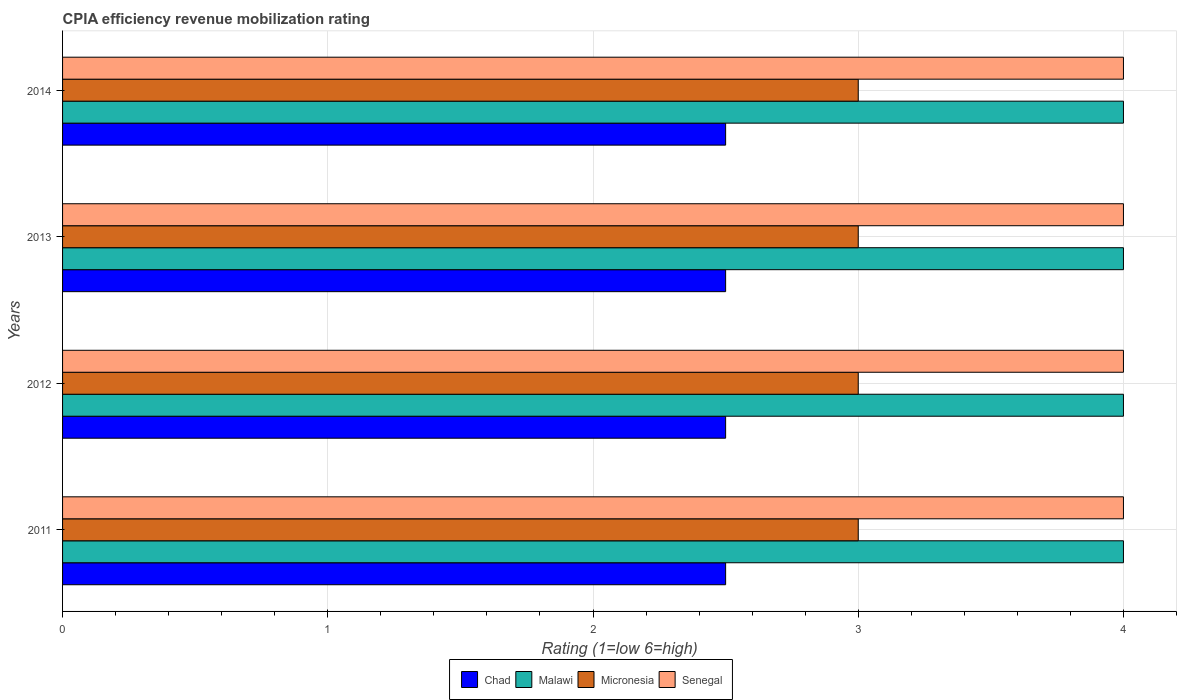How many groups of bars are there?
Provide a succinct answer. 4. Are the number of bars per tick equal to the number of legend labels?
Your answer should be very brief. Yes. Are the number of bars on each tick of the Y-axis equal?
Your answer should be compact. Yes. How many bars are there on the 2nd tick from the top?
Offer a very short reply. 4. In how many cases, is the number of bars for a given year not equal to the number of legend labels?
Provide a short and direct response. 0. Across all years, what is the maximum CPIA rating in Malawi?
Your answer should be compact. 4. In which year was the CPIA rating in Malawi maximum?
Give a very brief answer. 2011. In which year was the CPIA rating in Senegal minimum?
Your response must be concise. 2011. What is the total CPIA rating in Malawi in the graph?
Offer a very short reply. 16. What is the difference between the CPIA rating in Senegal in 2013 and that in 2014?
Ensure brevity in your answer.  0. What is the average CPIA rating in Chad per year?
Provide a short and direct response. 2.5. In how many years, is the CPIA rating in Senegal greater than 3.4 ?
Your answer should be very brief. 4. What is the ratio of the CPIA rating in Micronesia in 2011 to that in 2014?
Make the answer very short. 1. Is the CPIA rating in Micronesia in 2012 less than that in 2014?
Provide a short and direct response. No. What is the difference between the highest and the lowest CPIA rating in Malawi?
Your response must be concise. 0. In how many years, is the CPIA rating in Malawi greater than the average CPIA rating in Malawi taken over all years?
Your answer should be compact. 0. Is the sum of the CPIA rating in Chad in 2013 and 2014 greater than the maximum CPIA rating in Malawi across all years?
Ensure brevity in your answer.  Yes. Is it the case that in every year, the sum of the CPIA rating in Chad and CPIA rating in Micronesia is greater than the sum of CPIA rating in Senegal and CPIA rating in Malawi?
Your response must be concise. Yes. What does the 3rd bar from the top in 2013 represents?
Provide a succinct answer. Malawi. What does the 2nd bar from the bottom in 2011 represents?
Offer a terse response. Malawi. Is it the case that in every year, the sum of the CPIA rating in Chad and CPIA rating in Senegal is greater than the CPIA rating in Micronesia?
Your response must be concise. Yes. Are all the bars in the graph horizontal?
Offer a very short reply. Yes. How many years are there in the graph?
Ensure brevity in your answer.  4. What is the difference between two consecutive major ticks on the X-axis?
Give a very brief answer. 1. Does the graph contain any zero values?
Your response must be concise. No. Where does the legend appear in the graph?
Keep it short and to the point. Bottom center. What is the title of the graph?
Your response must be concise. CPIA efficiency revenue mobilization rating. What is the label or title of the X-axis?
Offer a terse response. Rating (1=low 6=high). What is the label or title of the Y-axis?
Make the answer very short. Years. What is the Rating (1=low 6=high) in Malawi in 2011?
Provide a succinct answer. 4. What is the Rating (1=low 6=high) in Senegal in 2011?
Ensure brevity in your answer.  4. What is the Rating (1=low 6=high) of Micronesia in 2012?
Offer a terse response. 3. What is the Rating (1=low 6=high) in Senegal in 2012?
Offer a terse response. 4. What is the Rating (1=low 6=high) in Malawi in 2013?
Your answer should be compact. 4. What is the Rating (1=low 6=high) of Malawi in 2014?
Your answer should be very brief. 4. What is the Rating (1=low 6=high) of Micronesia in 2014?
Keep it short and to the point. 3. Across all years, what is the maximum Rating (1=low 6=high) of Chad?
Your response must be concise. 2.5. Across all years, what is the minimum Rating (1=low 6=high) of Chad?
Keep it short and to the point. 2.5. Across all years, what is the minimum Rating (1=low 6=high) in Malawi?
Your response must be concise. 4. Across all years, what is the minimum Rating (1=low 6=high) of Micronesia?
Provide a short and direct response. 3. Across all years, what is the minimum Rating (1=low 6=high) of Senegal?
Give a very brief answer. 4. What is the total Rating (1=low 6=high) of Chad in the graph?
Ensure brevity in your answer.  10. What is the total Rating (1=low 6=high) of Malawi in the graph?
Give a very brief answer. 16. What is the total Rating (1=low 6=high) of Micronesia in the graph?
Keep it short and to the point. 12. What is the total Rating (1=low 6=high) of Senegal in the graph?
Provide a short and direct response. 16. What is the difference between the Rating (1=low 6=high) of Chad in 2011 and that in 2013?
Ensure brevity in your answer.  0. What is the difference between the Rating (1=low 6=high) in Senegal in 2011 and that in 2013?
Provide a succinct answer. 0. What is the difference between the Rating (1=low 6=high) in Chad in 2011 and that in 2014?
Your answer should be very brief. 0. What is the difference between the Rating (1=low 6=high) in Senegal in 2011 and that in 2014?
Give a very brief answer. 0. What is the difference between the Rating (1=low 6=high) in Chad in 2012 and that in 2013?
Give a very brief answer. 0. What is the difference between the Rating (1=low 6=high) of Senegal in 2012 and that in 2013?
Your response must be concise. 0. What is the difference between the Rating (1=low 6=high) of Micronesia in 2012 and that in 2014?
Provide a short and direct response. 0. What is the difference between the Rating (1=low 6=high) in Chad in 2013 and that in 2014?
Your answer should be very brief. 0. What is the difference between the Rating (1=low 6=high) of Chad in 2011 and the Rating (1=low 6=high) of Malawi in 2012?
Make the answer very short. -1.5. What is the difference between the Rating (1=low 6=high) of Chad in 2011 and the Rating (1=low 6=high) of Micronesia in 2012?
Make the answer very short. -0.5. What is the difference between the Rating (1=low 6=high) of Chad in 2011 and the Rating (1=low 6=high) of Senegal in 2012?
Your answer should be very brief. -1.5. What is the difference between the Rating (1=low 6=high) of Malawi in 2011 and the Rating (1=low 6=high) of Senegal in 2012?
Offer a very short reply. 0. What is the difference between the Rating (1=low 6=high) of Chad in 2011 and the Rating (1=low 6=high) of Malawi in 2013?
Your response must be concise. -1.5. What is the difference between the Rating (1=low 6=high) in Chad in 2011 and the Rating (1=low 6=high) in Senegal in 2013?
Make the answer very short. -1.5. What is the difference between the Rating (1=low 6=high) in Malawi in 2011 and the Rating (1=low 6=high) in Micronesia in 2013?
Your response must be concise. 1. What is the difference between the Rating (1=low 6=high) in Micronesia in 2011 and the Rating (1=low 6=high) in Senegal in 2013?
Offer a very short reply. -1. What is the difference between the Rating (1=low 6=high) of Chad in 2011 and the Rating (1=low 6=high) of Micronesia in 2014?
Offer a very short reply. -0.5. What is the difference between the Rating (1=low 6=high) in Chad in 2011 and the Rating (1=low 6=high) in Senegal in 2014?
Your answer should be compact. -1.5. What is the difference between the Rating (1=low 6=high) of Malawi in 2011 and the Rating (1=low 6=high) of Micronesia in 2014?
Give a very brief answer. 1. What is the difference between the Rating (1=low 6=high) in Malawi in 2011 and the Rating (1=low 6=high) in Senegal in 2014?
Offer a very short reply. 0. What is the difference between the Rating (1=low 6=high) of Micronesia in 2011 and the Rating (1=low 6=high) of Senegal in 2014?
Offer a terse response. -1. What is the difference between the Rating (1=low 6=high) of Chad in 2012 and the Rating (1=low 6=high) of Micronesia in 2013?
Give a very brief answer. -0.5. What is the difference between the Rating (1=low 6=high) in Malawi in 2012 and the Rating (1=low 6=high) in Micronesia in 2013?
Your response must be concise. 1. What is the difference between the Rating (1=low 6=high) of Chad in 2012 and the Rating (1=low 6=high) of Malawi in 2014?
Provide a succinct answer. -1.5. What is the difference between the Rating (1=low 6=high) of Micronesia in 2012 and the Rating (1=low 6=high) of Senegal in 2014?
Your response must be concise. -1. What is the difference between the Rating (1=low 6=high) in Chad in 2013 and the Rating (1=low 6=high) in Malawi in 2014?
Your answer should be very brief. -1.5. What is the difference between the Rating (1=low 6=high) in Chad in 2013 and the Rating (1=low 6=high) in Micronesia in 2014?
Give a very brief answer. -0.5. What is the difference between the Rating (1=low 6=high) of Malawi in 2013 and the Rating (1=low 6=high) of Micronesia in 2014?
Give a very brief answer. 1. What is the average Rating (1=low 6=high) of Malawi per year?
Ensure brevity in your answer.  4. What is the average Rating (1=low 6=high) of Micronesia per year?
Provide a succinct answer. 3. In the year 2011, what is the difference between the Rating (1=low 6=high) of Chad and Rating (1=low 6=high) of Malawi?
Your response must be concise. -1.5. In the year 2011, what is the difference between the Rating (1=low 6=high) of Chad and Rating (1=low 6=high) of Micronesia?
Your response must be concise. -0.5. In the year 2011, what is the difference between the Rating (1=low 6=high) in Chad and Rating (1=low 6=high) in Senegal?
Offer a very short reply. -1.5. In the year 2011, what is the difference between the Rating (1=low 6=high) of Malawi and Rating (1=low 6=high) of Senegal?
Your response must be concise. 0. In the year 2011, what is the difference between the Rating (1=low 6=high) of Micronesia and Rating (1=low 6=high) of Senegal?
Provide a succinct answer. -1. In the year 2012, what is the difference between the Rating (1=low 6=high) of Malawi and Rating (1=low 6=high) of Micronesia?
Offer a terse response. 1. In the year 2013, what is the difference between the Rating (1=low 6=high) of Chad and Rating (1=low 6=high) of Malawi?
Offer a very short reply. -1.5. In the year 2013, what is the difference between the Rating (1=low 6=high) of Chad and Rating (1=low 6=high) of Micronesia?
Provide a short and direct response. -0.5. In the year 2013, what is the difference between the Rating (1=low 6=high) of Chad and Rating (1=low 6=high) of Senegal?
Keep it short and to the point. -1.5. In the year 2014, what is the difference between the Rating (1=low 6=high) of Chad and Rating (1=low 6=high) of Malawi?
Keep it short and to the point. -1.5. In the year 2014, what is the difference between the Rating (1=low 6=high) in Chad and Rating (1=low 6=high) in Micronesia?
Provide a succinct answer. -0.5. What is the ratio of the Rating (1=low 6=high) of Micronesia in 2011 to that in 2012?
Offer a very short reply. 1. What is the ratio of the Rating (1=low 6=high) of Micronesia in 2011 to that in 2013?
Your response must be concise. 1. What is the ratio of the Rating (1=low 6=high) of Malawi in 2011 to that in 2014?
Ensure brevity in your answer.  1. What is the ratio of the Rating (1=low 6=high) in Micronesia in 2011 to that in 2014?
Offer a terse response. 1. What is the ratio of the Rating (1=low 6=high) in Malawi in 2012 to that in 2013?
Provide a short and direct response. 1. What is the ratio of the Rating (1=low 6=high) in Senegal in 2012 to that in 2013?
Keep it short and to the point. 1. What is the ratio of the Rating (1=low 6=high) of Malawi in 2012 to that in 2014?
Your response must be concise. 1. What is the ratio of the Rating (1=low 6=high) of Senegal in 2012 to that in 2014?
Your answer should be very brief. 1. What is the ratio of the Rating (1=low 6=high) in Chad in 2013 to that in 2014?
Keep it short and to the point. 1. What is the ratio of the Rating (1=low 6=high) in Malawi in 2013 to that in 2014?
Your answer should be very brief. 1. What is the ratio of the Rating (1=low 6=high) of Senegal in 2013 to that in 2014?
Make the answer very short. 1. What is the difference between the highest and the lowest Rating (1=low 6=high) of Micronesia?
Offer a terse response. 0. What is the difference between the highest and the lowest Rating (1=low 6=high) in Senegal?
Your answer should be compact. 0. 